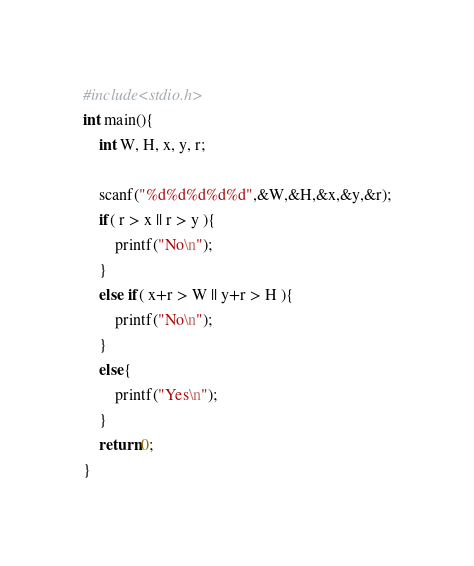Convert code to text. <code><loc_0><loc_0><loc_500><loc_500><_C_>#include<stdio.h>
int main(){
    int W, H, x, y, r;

    scanf("%d%d%d%d%d",&W,&H,&x,&y,&r);
    if( r > x || r > y ){
        printf("No\n");
    }
    else if( x+r > W || y+r > H ){
        printf("No\n");
    }
    else{
        printf("Yes\n");
    }
    return 0;
}</code> 